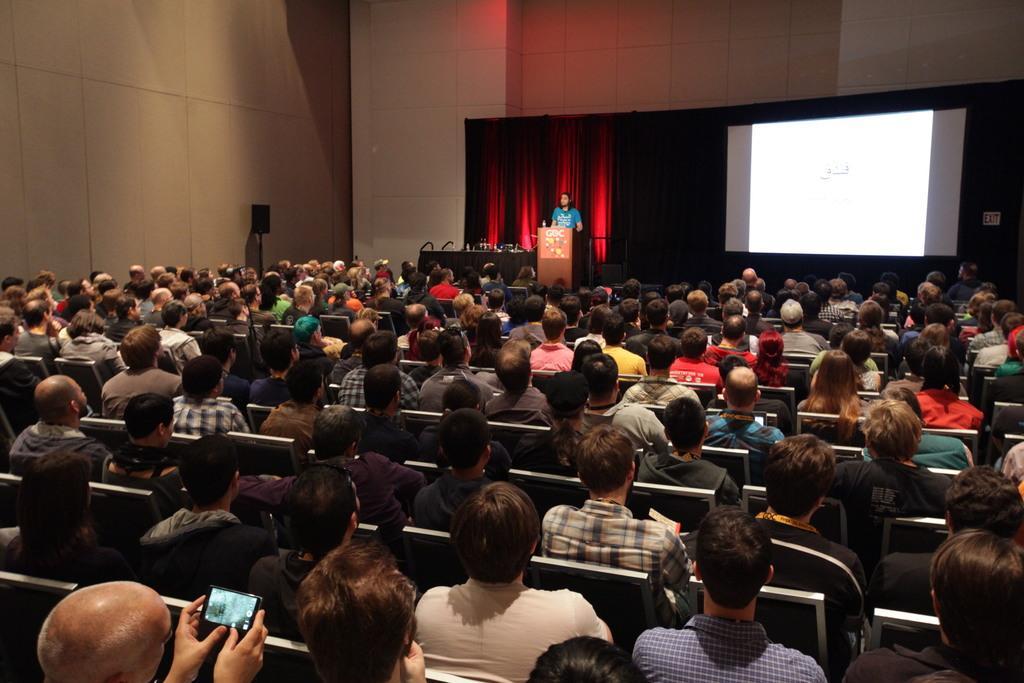Can you describe this image briefly? In this picture we can see a group of people sitting on chairs where a man standing at podium, mobile, screen, curtains and in the background we can see wall. 